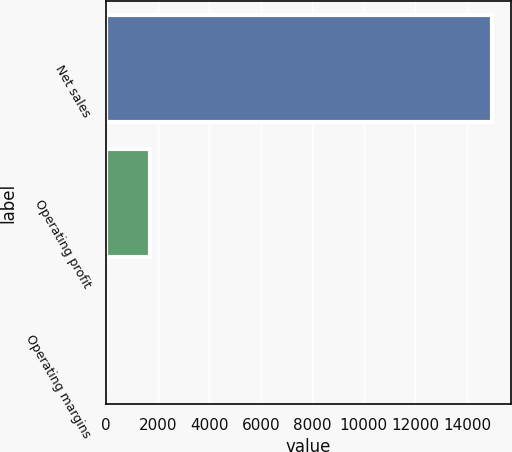Convert chart to OTSL. <chart><loc_0><loc_0><loc_500><loc_500><bar_chart><fcel>Net sales<fcel>Operating profit<fcel>Operating margins<nl><fcel>14953<fcel>1699<fcel>11.4<nl></chart> 